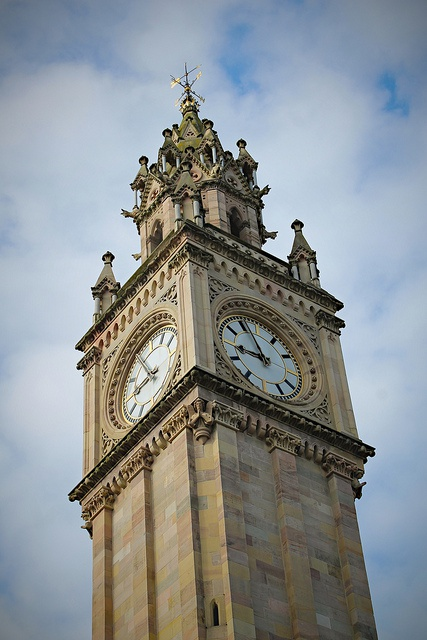Describe the objects in this image and their specific colors. I can see clock in gray, darkgray, and black tones and clock in gray, lightgray, darkgray, and khaki tones in this image. 